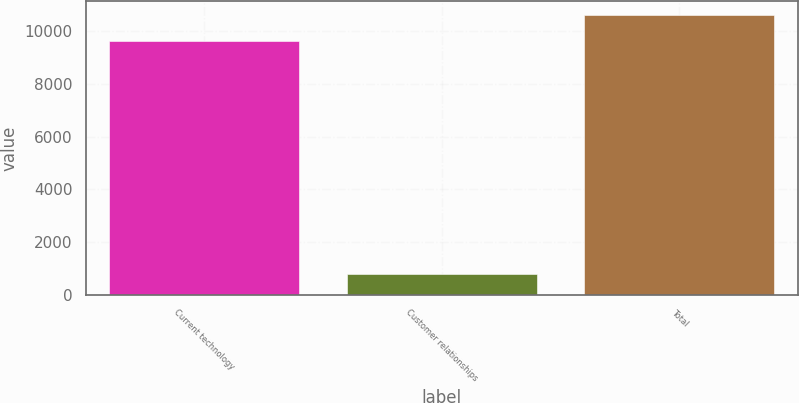<chart> <loc_0><loc_0><loc_500><loc_500><bar_chart><fcel>Current technology<fcel>Customer relationships<fcel>Total<nl><fcel>9632<fcel>783<fcel>10595.2<nl></chart> 